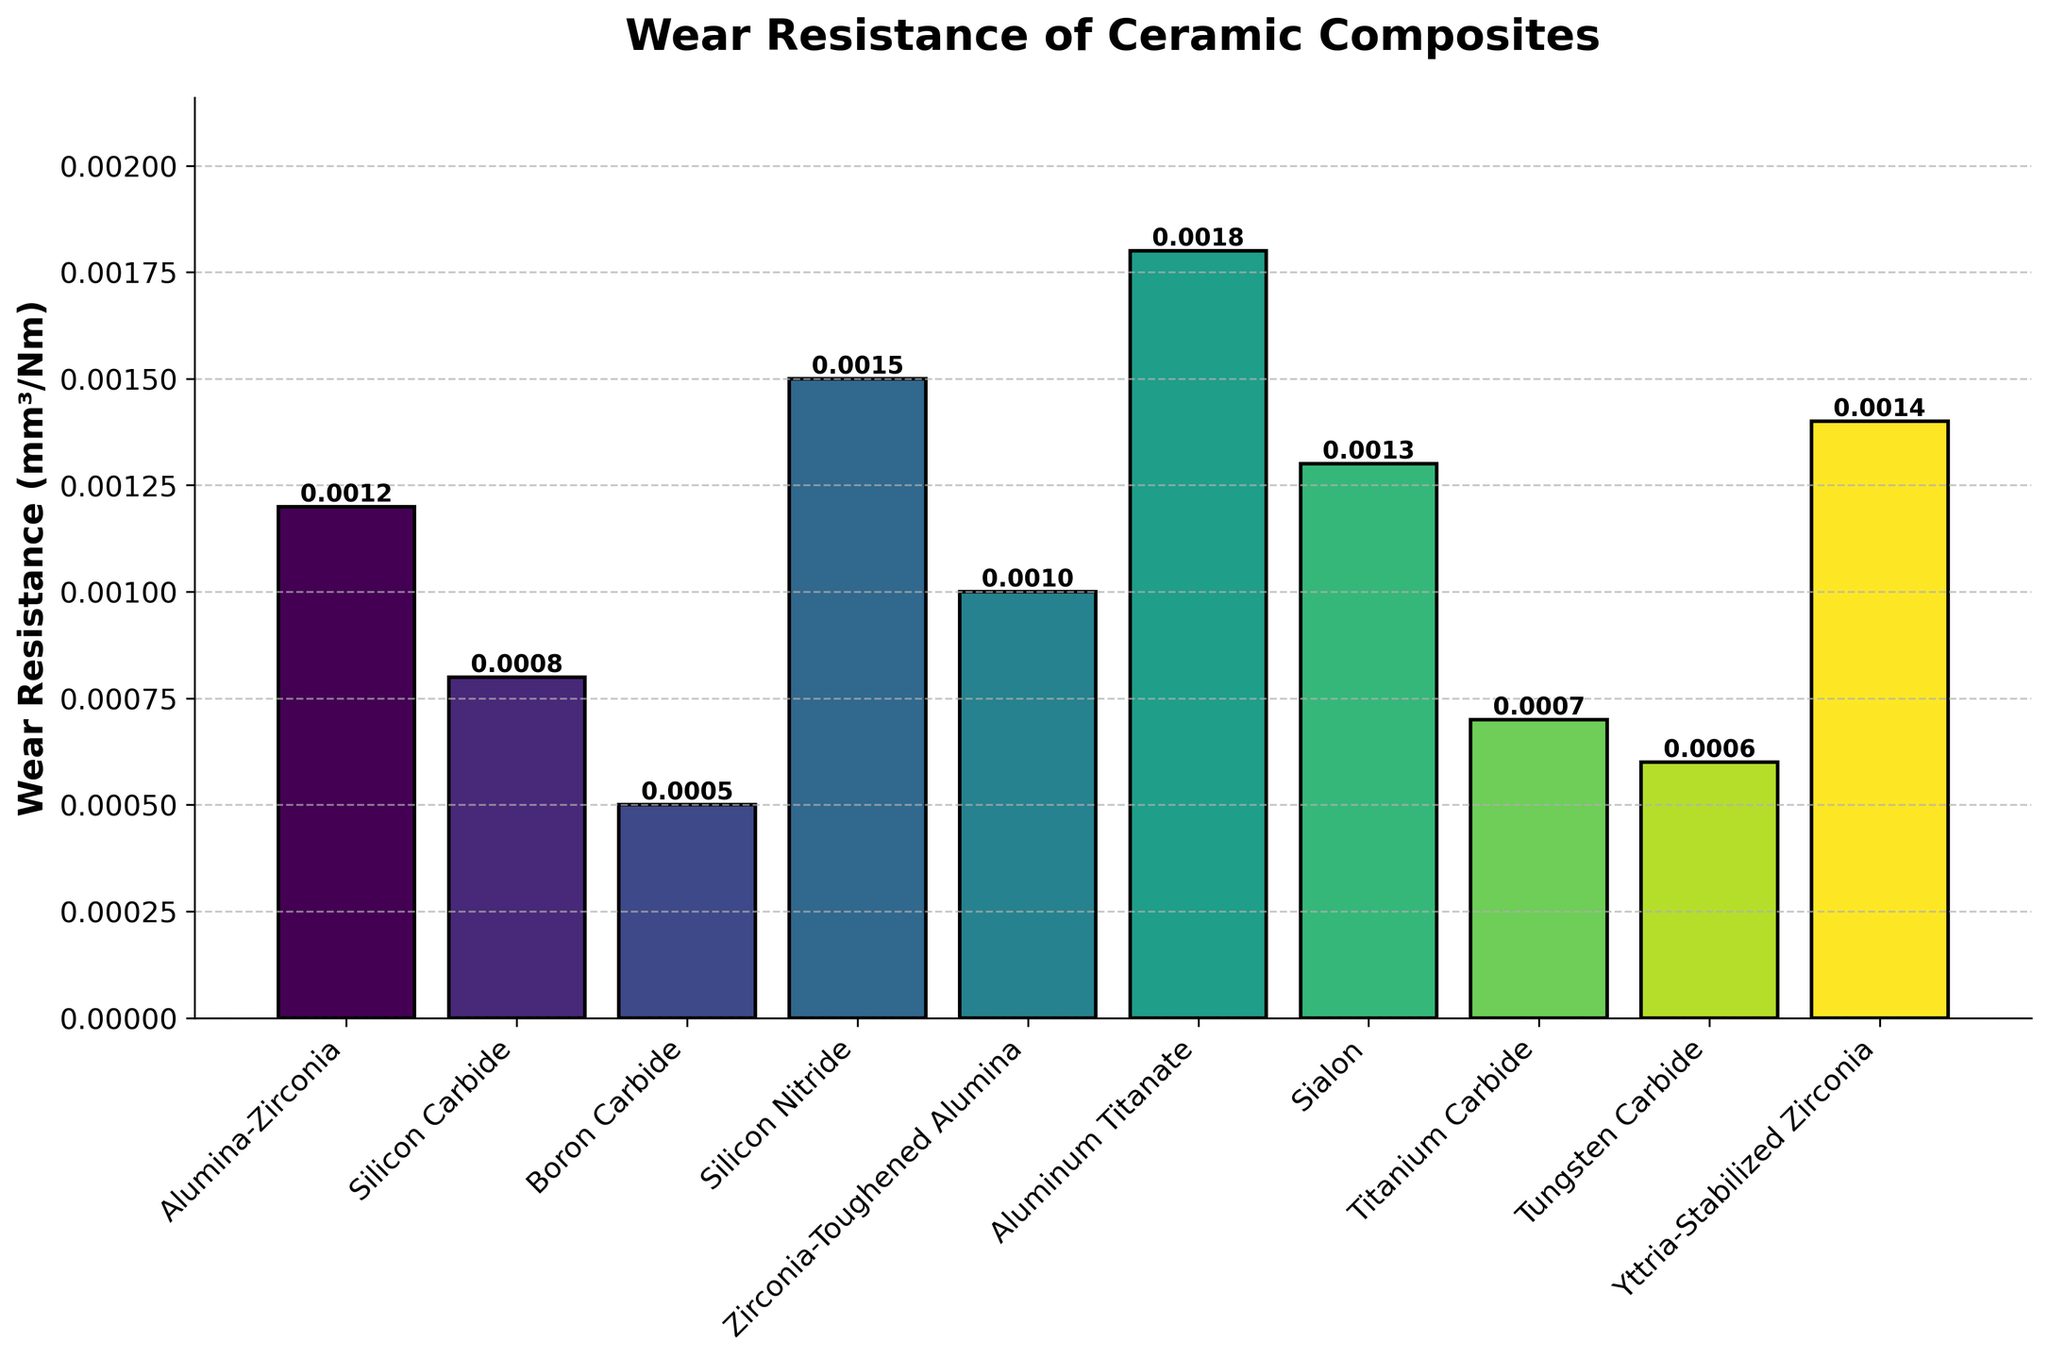Which ceramic composite has the lowest wear resistance? The lowest wear resistance can be identified by looking at the shortest bar in the figure. Here, Aluminum Titanate has the shortest bar, indicating it has the highest wear resistance value.
Answer: Aluminum Titanate Which material has higher wear resistance, Silicon Carbide or Titanium Carbide? We compare the heights of the bars for Silicon Carbide and Titanium Carbide. The bar representing Silicon Carbide is taller than the bar representing Titanium Carbide, indicating higher wear resistance.
Answer: Silicon Carbide How much more wear-resistant is Boron Carbide compared to Yttria-Stabilized Zirconia? We find the wear resistance values for Boron Carbide (0.0005 mm³/Nm) and Yttria-Stabilized Zirconia (0.0014 mm³/Nm) from the figure. Then, we subtract the smaller value from the larger one: 0.0014 - 0.0005 = 0.0009 mm³/Nm.
Answer: 0.0009 mm³/Nm What is the average wear resistance of Alumina-Zirconia, Silicon Carbide, and Boron Carbide? We add the wear resistance values for Alumina-Zirconia (0.0012 mm³/Nm), Silicon Carbide (0.0008 mm³/Nm), and Boron Carbide (0.0005 mm³/Nm), and then divide by 3. (0.0012 + 0.0008 + 0.0005) / 3 = 0.000833 mm³/Nm.
Answer: 0.000833 mm³/Nm Which material shows better wear resistance: Sialon or Yttria-Stabilized Zirconia? By comparing the bar heights for Sialon and Yttria-Stabilized Zirconia, we see that the bar representing Yttria-Stabilized Zirconia is higher, meaning Sialon has better wear resistance.
Answer: Sialon What is the difference in wear resistance between the materials with the highest and lowest values? The highest wear resistance is Aluminum Titanate (0.0018 mm³/Nm), and the lowest is Boron Carbide (0.0005 mm³/Nm). Subtract the lowest value from the highest: 0.0018 - 0.0005 = 0.0013 mm³/Nm.
Answer: 0.0013 mm³/Nm How many materials have wear resistance values less than 0.001 mm³/Nm? By counting the bars with heights less than 0.001 mm³/Nm, we find 4 materials: Boron Carbide, Silicon Carbide, Titanium Carbide, and Tungsten Carbide.
Answer: 4 If we group the materials into two categories: those with wear resistance values less than 0.001 mm³/Nm and those with values greater than or equal to 0.001 mm³/Nm, how many materials fall into each category? Count the bars less than 0.001 mm³/Nm (4) and equal to or above 0.001 mm³/Nm (6).
Answer: Less than 0.001: 4, 0.001 and above: 6 